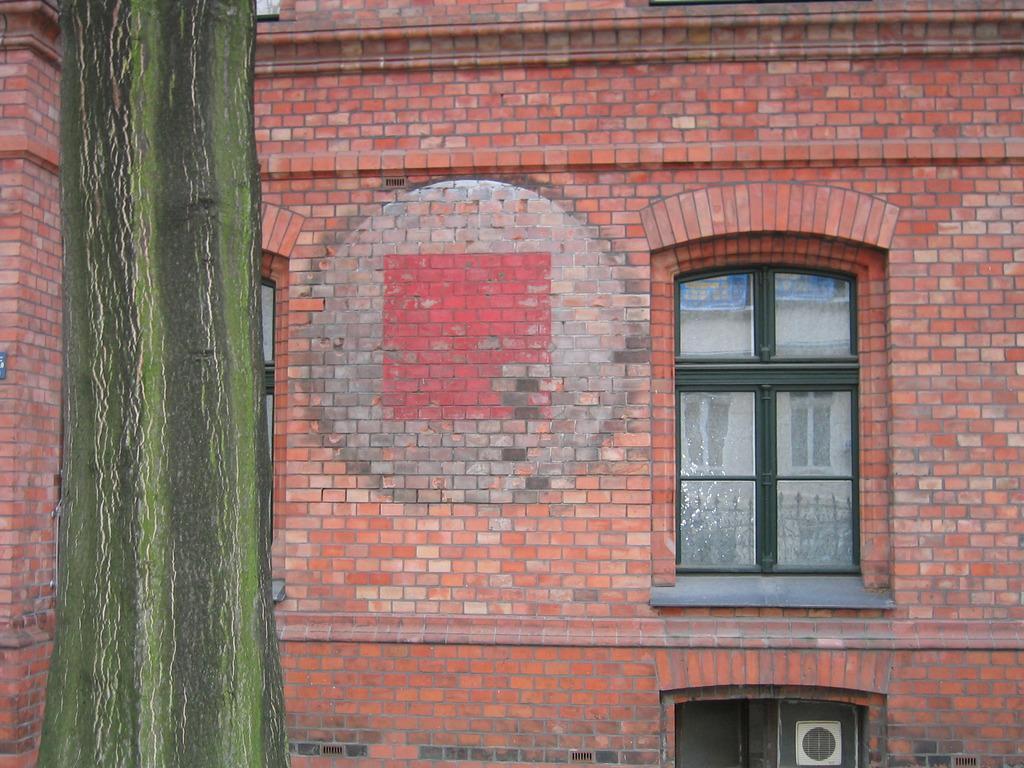Could you give a brief overview of what you see in this image? The picture consists of brick wall, windows and trunk of a tree towards left. 